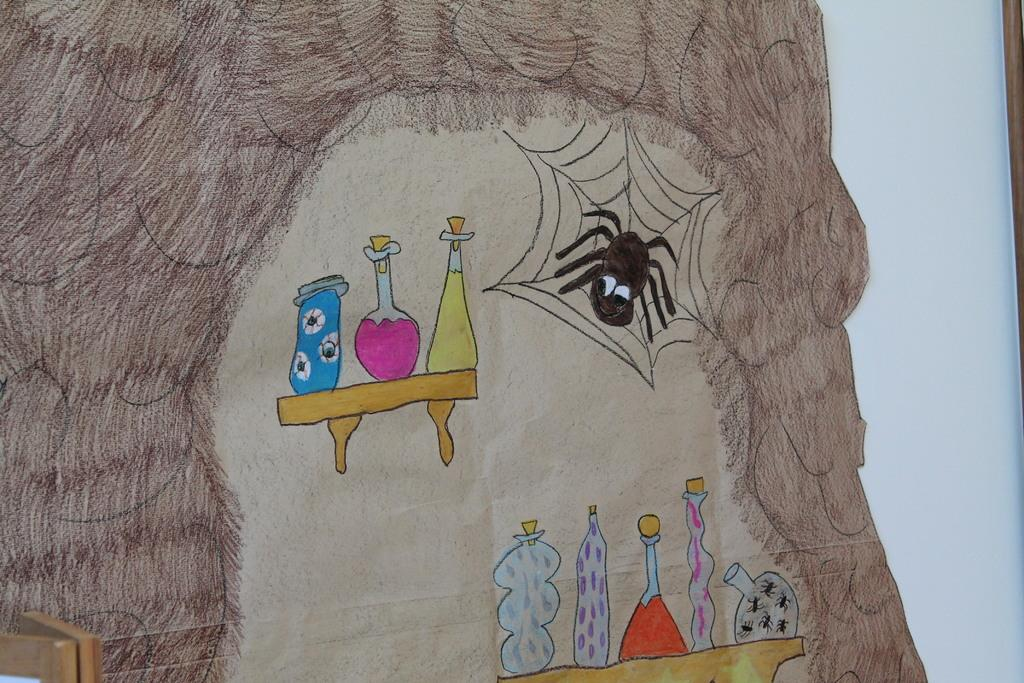What is depicted in the image? There is a drawing in the image. What type of creature is present in the drawing? There is a spider in the image. What is the spider associated with in the image? There is a spider web in the image. What else can be seen in the image besides the drawing and spider? There are objects in the image. What is visible in the background of the image? There is a whiteboard in the background of the image. What type of pet is the maid holding in the image? There is no maid or pet present in the image. What nation is represented by the drawing in the image? The drawing does not represent any specific nation; it features a spider and a spider web. 